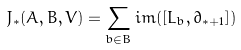<formula> <loc_0><loc_0><loc_500><loc_500>J _ { * } ( A , B , V ) = \sum _ { b \in B } i m ( [ L _ { b } , \partial _ { * + 1 } ] )</formula> 